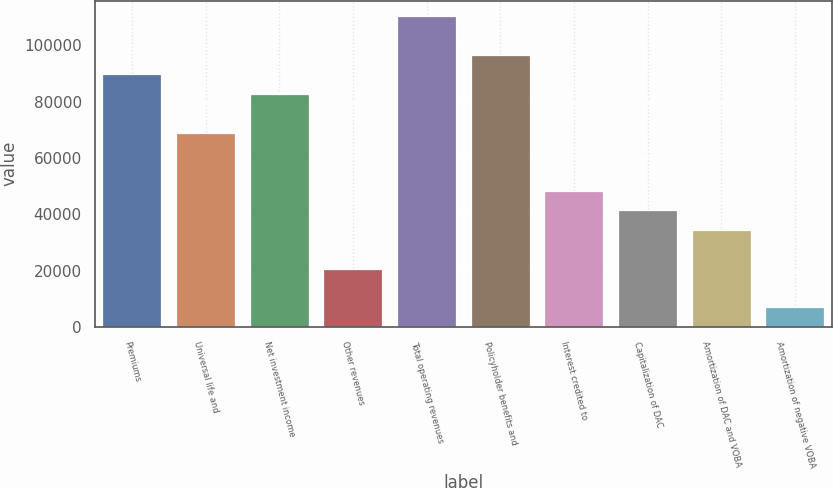Convert chart to OTSL. <chart><loc_0><loc_0><loc_500><loc_500><bar_chart><fcel>Premiums<fcel>Universal life and<fcel>Net investment income<fcel>Other revenues<fcel>Total operating revenues<fcel>Policyholder benefits and<fcel>Interest credited to<fcel>Capitalization of DAC<fcel>Amortization of DAC and VOBA<fcel>Amortization of negative VOBA<nl><fcel>89684.2<fcel>69016<fcel>82794.8<fcel>20790.2<fcel>110352<fcel>96573.6<fcel>48347.8<fcel>41458.4<fcel>34569<fcel>7011.4<nl></chart> 